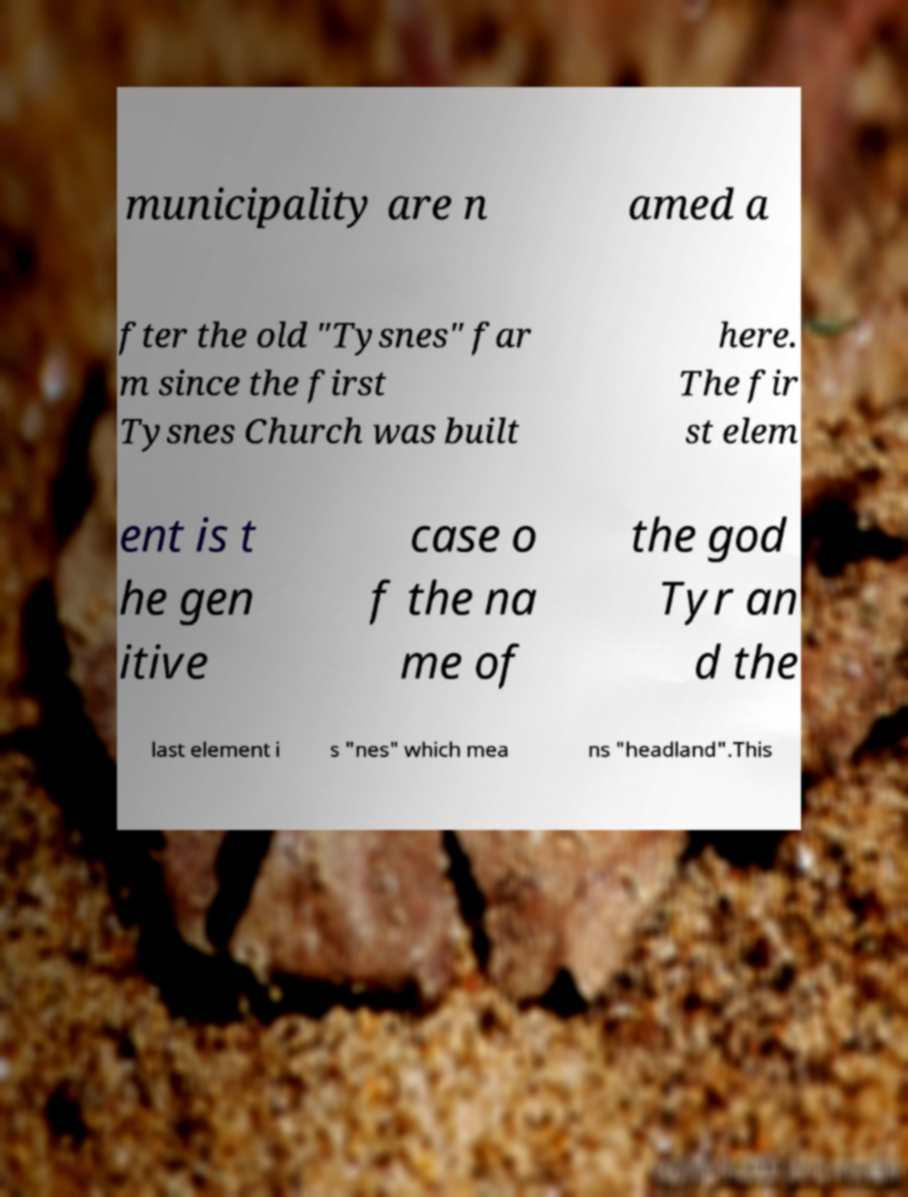Please read and relay the text visible in this image. What does it say? municipality are n amed a fter the old "Tysnes" far m since the first Tysnes Church was built here. The fir st elem ent is t he gen itive case o f the na me of the god Tyr an d the last element i s "nes" which mea ns "headland".This 